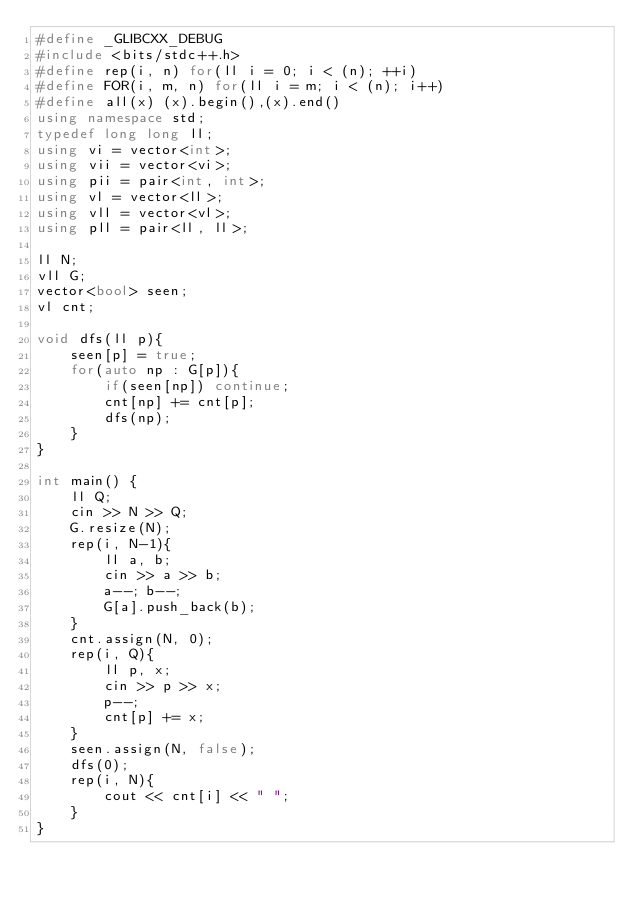<code> <loc_0><loc_0><loc_500><loc_500><_C++_>#define _GLIBCXX_DEBUG
#include <bits/stdc++.h>
#define rep(i, n) for(ll i = 0; i < (n); ++i)
#define FOR(i, m, n) for(ll i = m; i < (n); i++)
#define all(x) (x).begin(),(x).end()
using namespace std;
typedef long long ll;
using vi = vector<int>;
using vii = vector<vi>;
using pii = pair<int, int>; 
using vl = vector<ll>;
using vll = vector<vl>;
using pll = pair<ll, ll>;

ll N;
vll G;
vector<bool> seen;
vl cnt;

void dfs(ll p){
    seen[p] = true;
    for(auto np : G[p]){
        if(seen[np]) continue;
        cnt[np] += cnt[p];
        dfs(np);
    }
}

int main() {
    ll Q;
    cin >> N >> Q;
    G.resize(N);
    rep(i, N-1){
        ll a, b;
        cin >> a >> b;
        a--; b--;
        G[a].push_back(b);
    }
    cnt.assign(N, 0);
    rep(i, Q){
        ll p, x;
        cin >> p >> x;
        p--;
        cnt[p] += x;
    }
    seen.assign(N, false);
    dfs(0);
    rep(i, N){
        cout << cnt[i] << " ";
    }
}</code> 